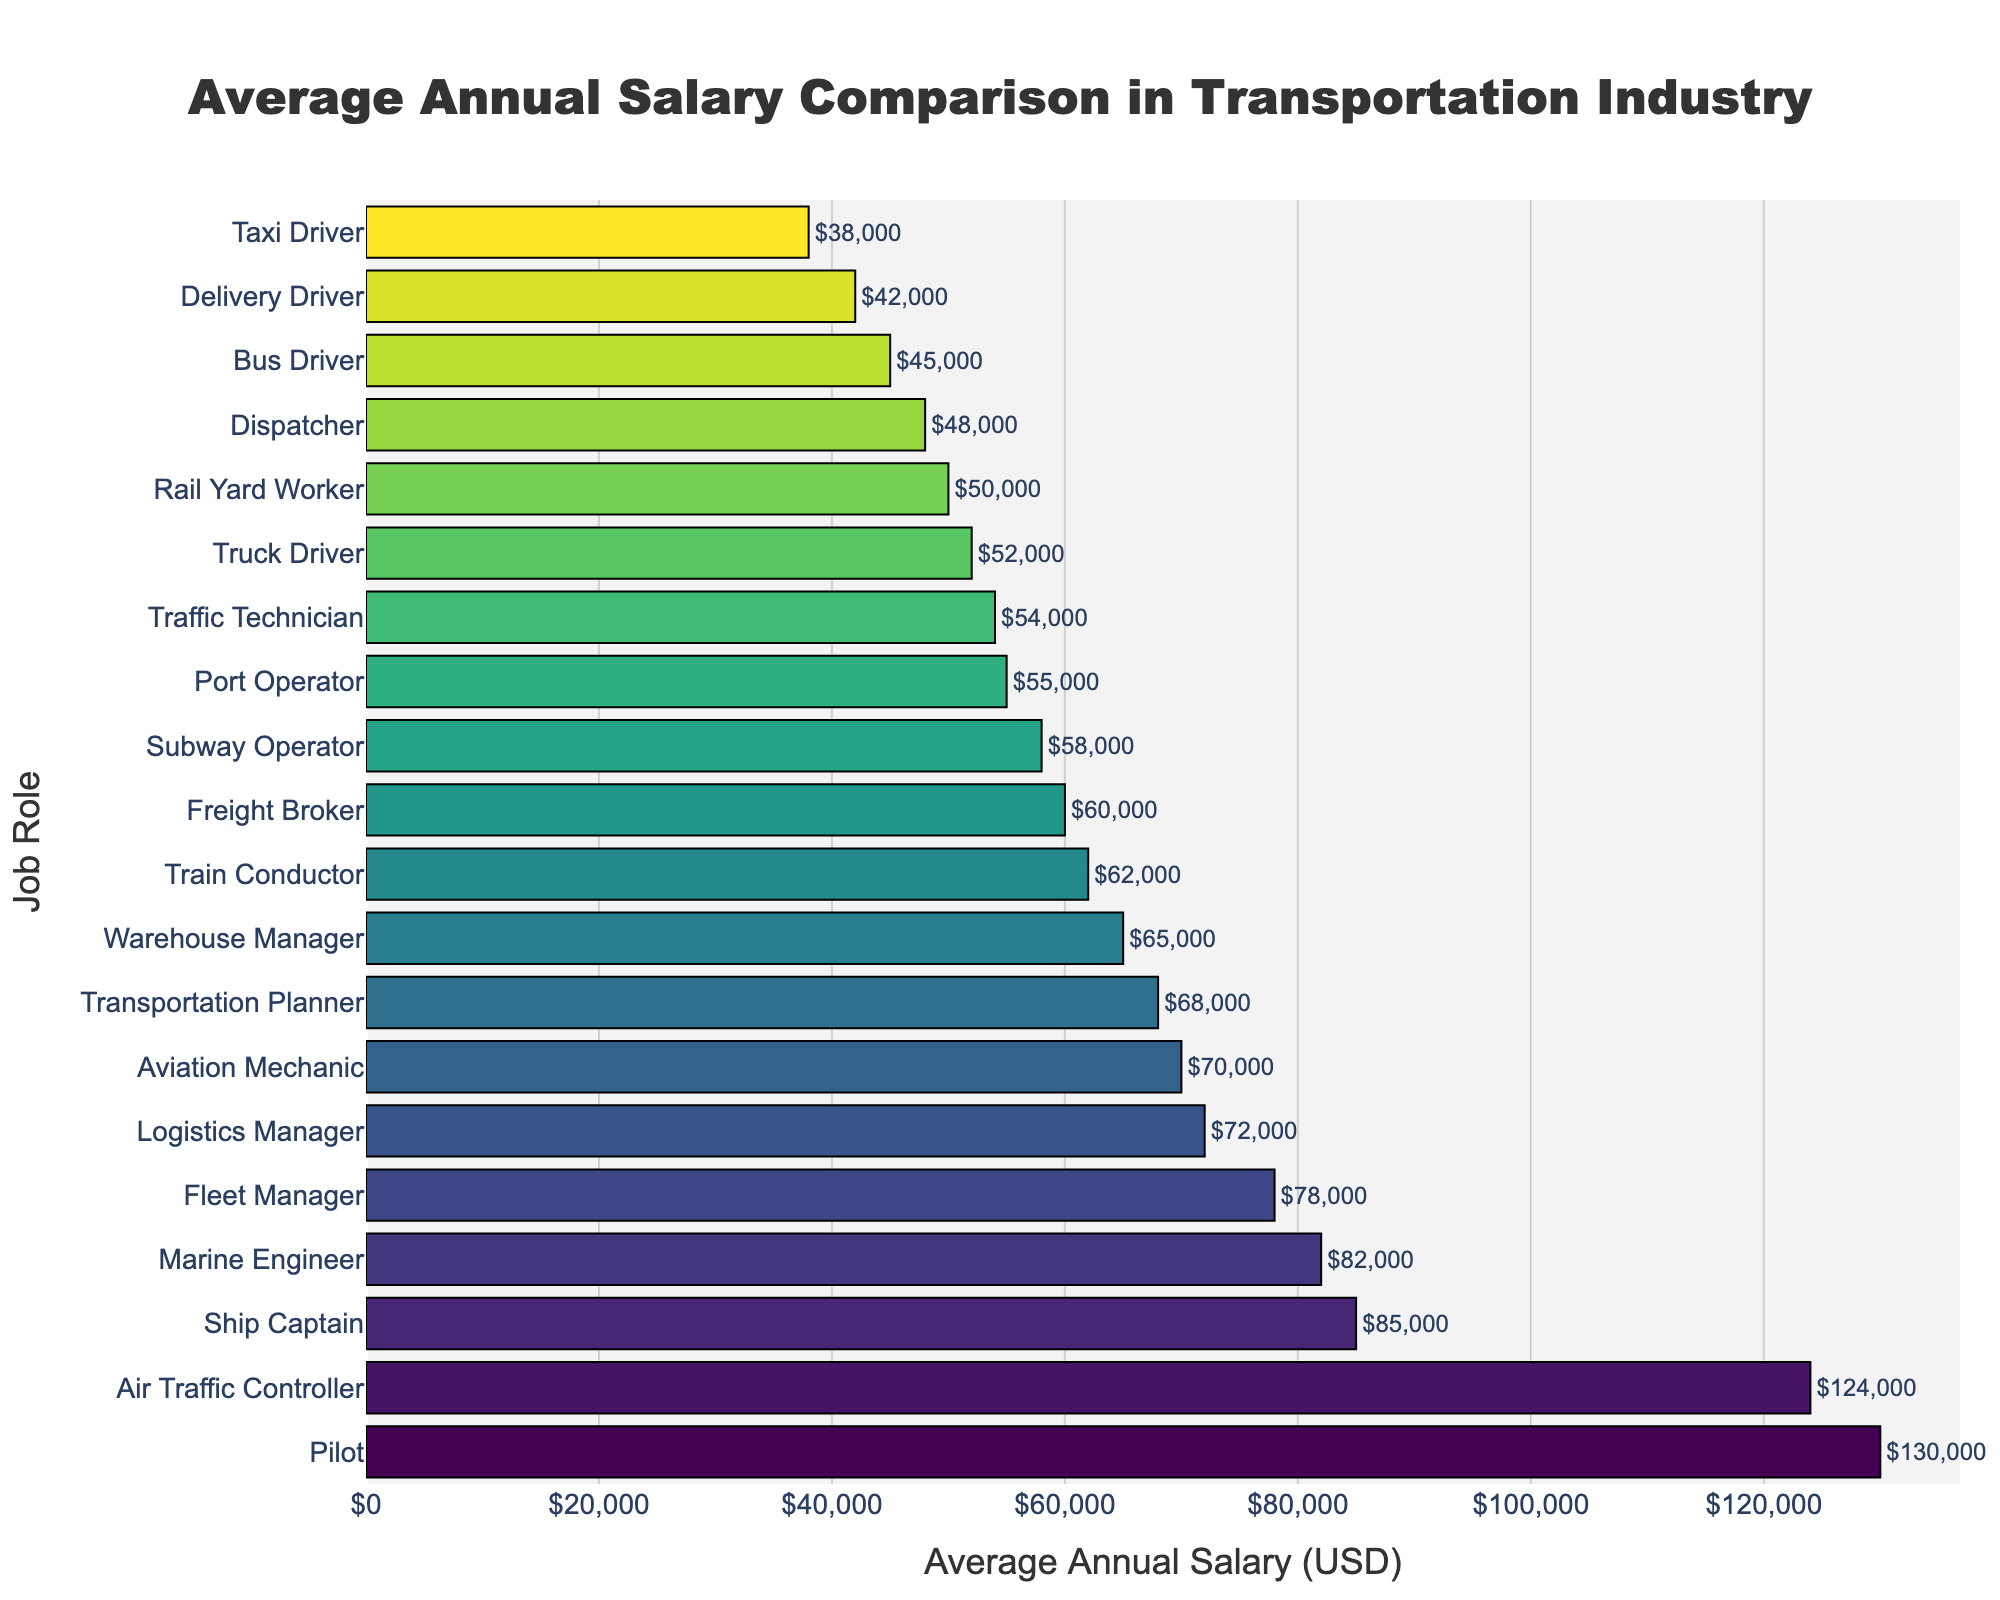What job role has the highest average annual salary? The chart shows the top of the bar for the highest salary, which corresponds to the Pilot.
Answer: Pilot Which job role has a higher average annual salary, Bus Driver or Truck Driver? The bar for Truck Driver is longer than the bar for Bus Driver, indicating a higher salary.
Answer: Truck Driver How much more does a Logistics Manager earn annually compared to a Dispatcher? The bar of Logistics Manager shows $72,000, and the bar of Dispatcher shows $48,000. The difference is $72,000 - $48,000.
Answer: $24,000 What is the combined average annual salary of a Delivery Driver and an Aviation Mechanic? The Delivery Driver has a salary of $42,000, and the Aviation Mechanic has a salary of $70,000. Adding these gives $42,000 + $70,000.
Answer: $112,000 Which job roles have a salary over $100,000? From the bars visible in the chart, only Air Traffic Controller ($124,000) and Pilot ($130,000) have salaries over $100,000.
Answer: Air Traffic Controller, Pilot Is the salary of a Subway Operator closer to the salary of a Truck Driver or a Train Conductor? The average salary of a Subway Operator is $58,000. The Truck Driver earns $52,000 and the Train Conductor earns $62,000. The Subway Operator's salary is closer to the Truck Driver's salary because $58,000 is nearer to $52,000 than $62,000.
Answer: Truck Driver How much less does a Taxi Driver earn compared to a Freight Broker? The average salary of a Taxi Driver is $38,000, and the Freight Broker earns $60,000. The difference is $60,000 - $38,000.
Answer: $22,000 What is the average annual salary of the three lowest-paying job roles? The three lowest-paying job roles are Taxi Driver ($38,000), Delivery Driver ($42,000), and Bus Driver ($45,000). The average is calculated by summing these values and dividing by 3: (38,000 + 42,000 + 45,000) / 3.
Answer: $41,667 Identify the role with the closest salary to the median salary on the chart. To find the median, sort the salaries: $38,000 (Taxi Driver), $42,000 (Delivery Driver), $45,000 (Bus Driver), $48,000 (Dispatcher), $50,000 (Rail Yard Worker), $52,000 (Truck Driver), $54,000 (Traffic Technician), $55,000 (Port Operator), $58,000 (Subway Operator), $60,000 (Freight Broker), $62,000 (Train Conductor), $65,000 (Warehouse Manager), $68,000 (Transportation Planner), $70,000 (Aviation Mechanic), $72,000 (Logistics Manager), $78,000 (Fleet Manager), $82,000 (Marine Engineer), $85,000 (Ship Captain), $124,000 (Air Traffic Controller), $130,000 (Pilot). The median value is between Port Operator and Subway Operator, closest to Subway Operator.
Answer: Subway Operator What is the difference in average annual salary between the highest and lowest paying job roles? The highest paying job role is Pilot with $130,000, and the lowest is Taxi Driver with $38,000. The difference is $130,000 - $38,000.
Answer: $92,000 